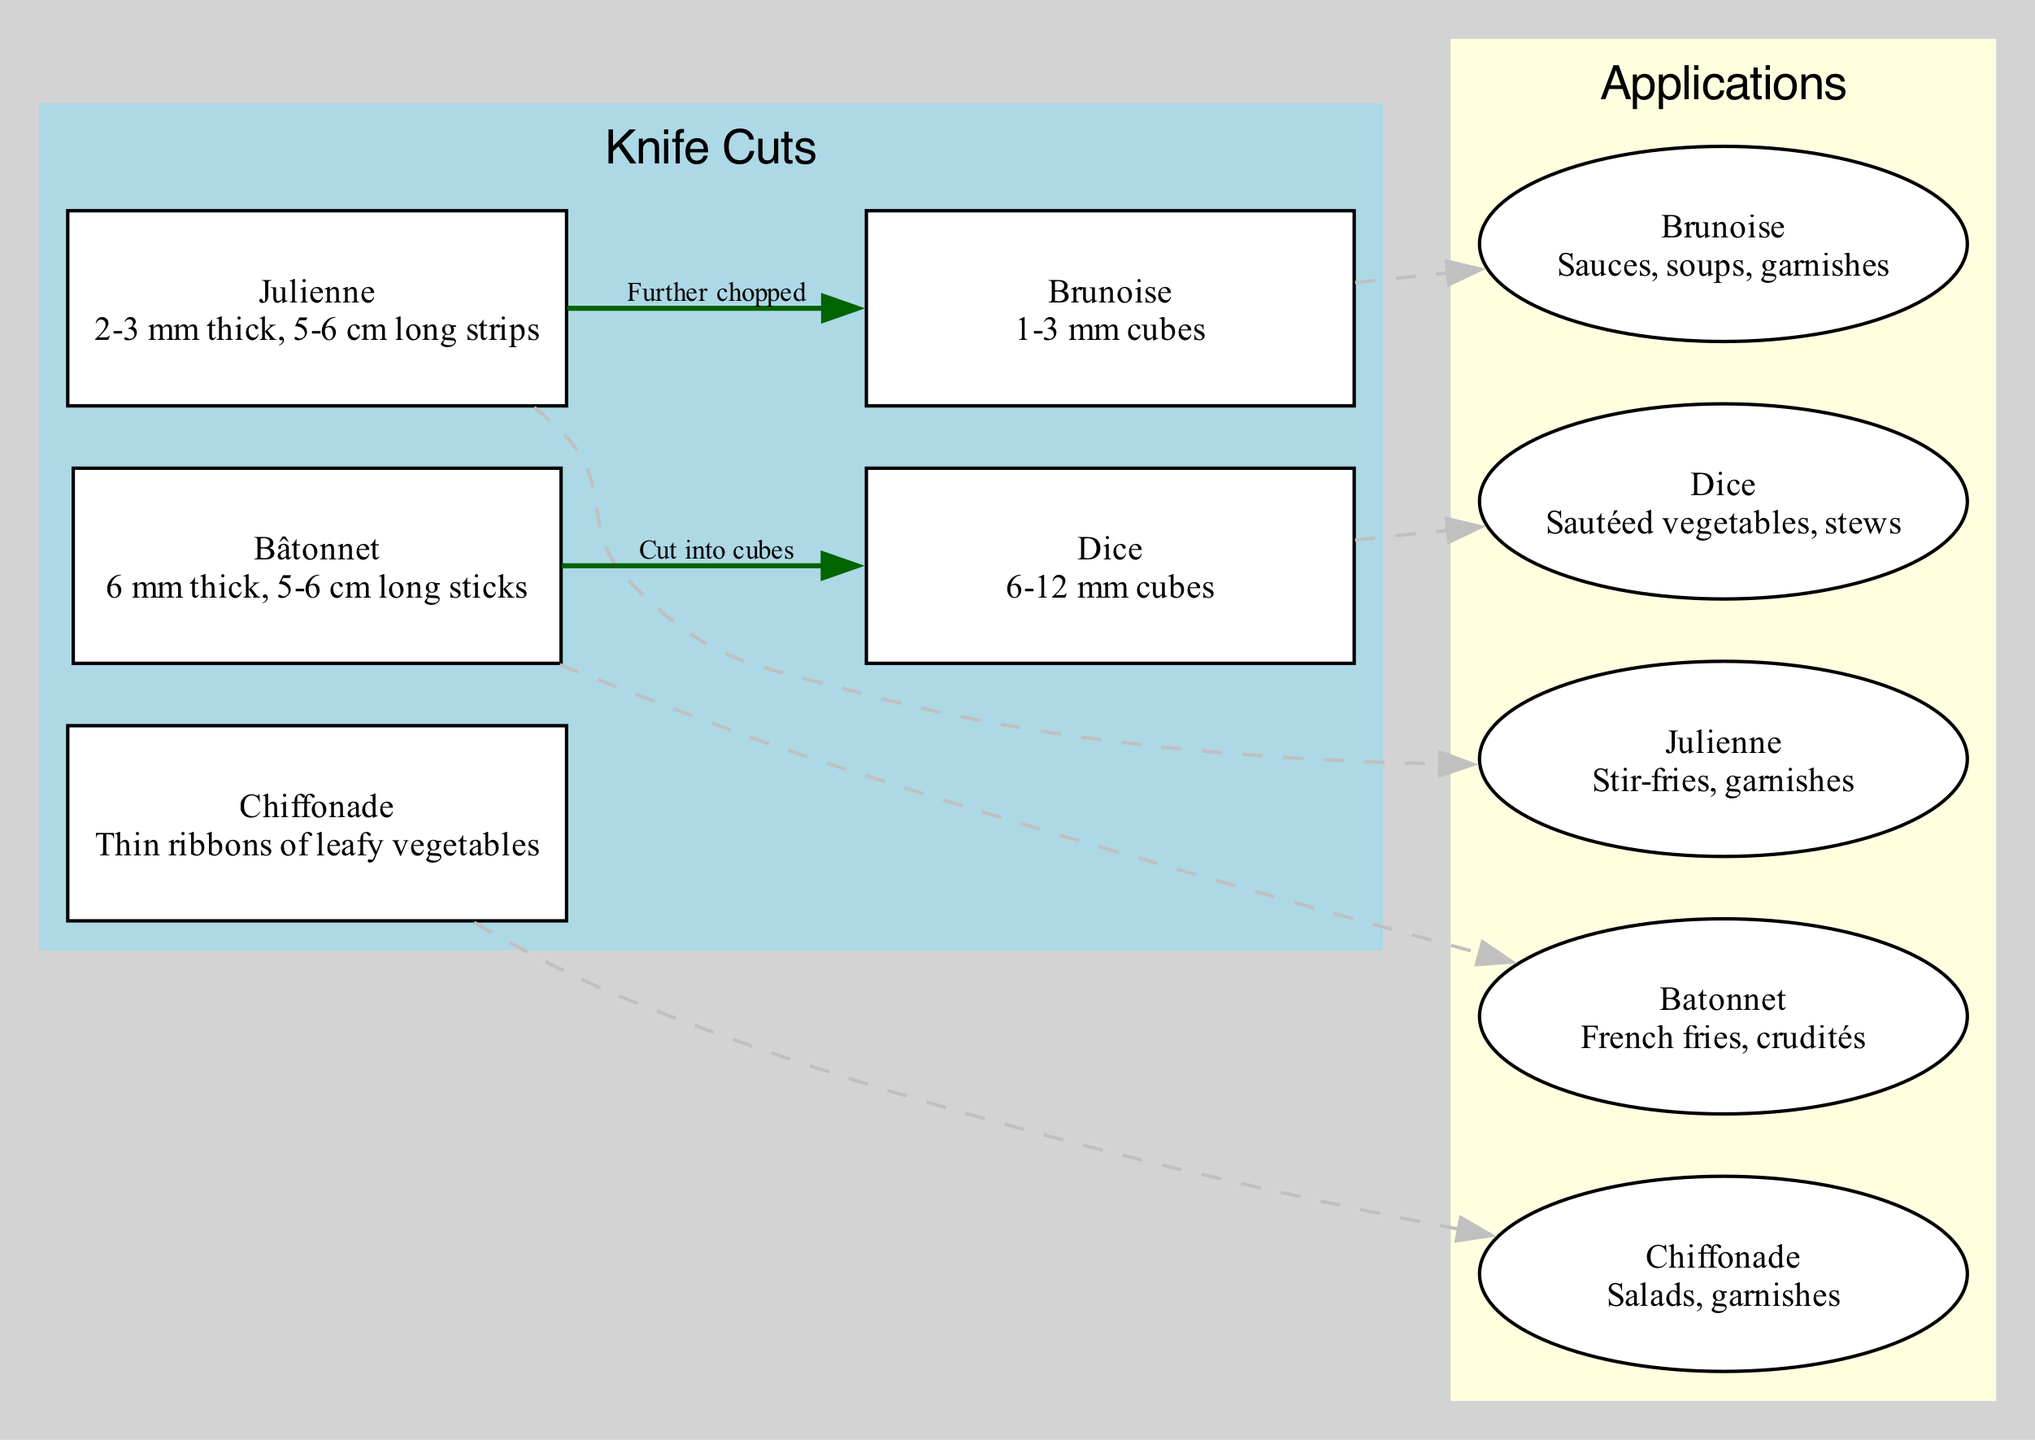What is the thickness of a Julienne cut? The description of the Julienne node states it is "2-3 mm thick." Hence, the answer is derived directly from that specific label.
Answer: 2-3 mm How many knife cuts are listed in the diagram? The diagram contains five distinct knife cuts labeled as Julienne, Brunoise, Chiffonade, Batonnet, and Dice. Hence, counting each cut gives us the total.
Answer: 5 What is the length of a Batonnet cut? The description of the Batonnet node specifies that it is "5-6 cm long." This detail is explicitly mentioned, so the answer can be directly taken from the Batonnet node.
Answer: 5-6 cm Which cut can be further chopped into Brunoise? The edge labeled “Further chopped” leads from the Julienne node to the Brunoise node. This indicates that the Julienne cut can be further processed into Brunoise.
Answer: Julienne What applications are associated with the Brunoise cut? The applications section for the Brunoise cut lists "Sauces, soups, garnishes." This information is provided directly under the Brunoise application node, making it easy to identify.
Answer: Sauces, soups, garnishes What type of cut is primarily used for French fries? The application connected to the Batonnet cut states "French fries, crudités." This identifies Batonnet as the cut mainly used for preparing French fries.
Answer: Batonnet Which two cuts are connected by a “Cut into cubes” edge? The edge “Cut into cubes” connects the Batonnet node to the Dice node. By following the edge labels in the diagram, we can identify these cuts clearly.
Answer: Batonnet and Dice What is the primary usage of Chiffonade cut? The usage section for the Chiffonade cut indicates "Salads, garnishes." This information directly describes the intended applications for the Chiffonade cut from the diagram.
Answer: Salads, garnishes Which cut is the smallest in size, and what is that size? The Brunoise cut, with a size of "1-3 mm cubes," is the smallest as it refers to the dimensions of the cuts. Thus, after comparing all descriptions, this information is clearly outlined.
Answer: 1-3 mm cubes 